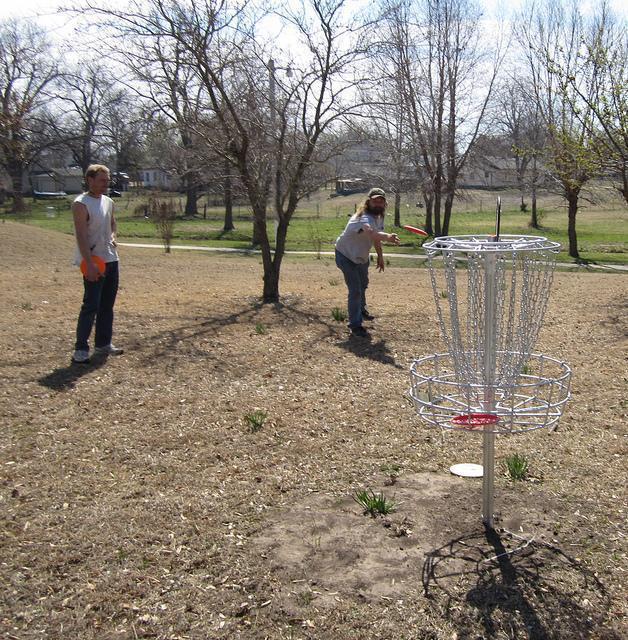What sport are the two men playing?
Indicate the correct choice and explain in the format: 'Answer: answer
Rationale: rationale.'
Options: Soccer, disc golf, basketball, baseball. Answer: disc golf.
Rationale: The men are throwing frisbees at a goal with a chain net. 